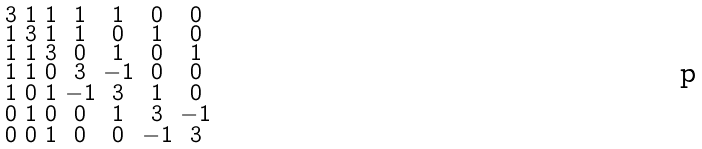<formula> <loc_0><loc_0><loc_500><loc_500>\begin{smallmatrix} 3 & 1 & 1 & 1 & 1 & 0 & 0 \\ 1 & 3 & 1 & 1 & 0 & 1 & 0 \\ 1 & 1 & 3 & 0 & 1 & 0 & 1 \\ 1 & 1 & 0 & 3 & - 1 & 0 & 0 \\ 1 & 0 & 1 & - 1 & 3 & 1 & 0 \\ 0 & 1 & 0 & 0 & 1 & 3 & - 1 \\ 0 & 0 & 1 & 0 & 0 & - 1 & 3 \end{smallmatrix}</formula> 